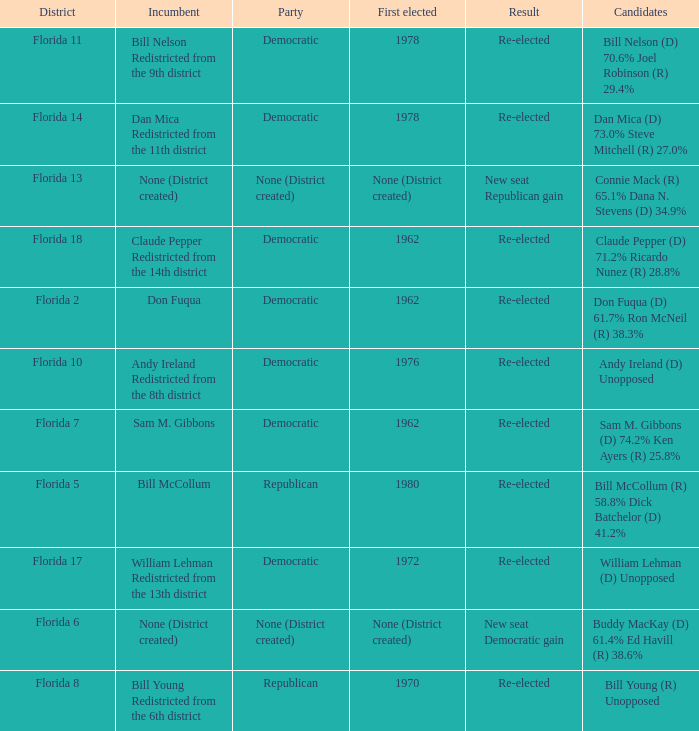 how many candidates with result being new seat democratic gain 1.0. 